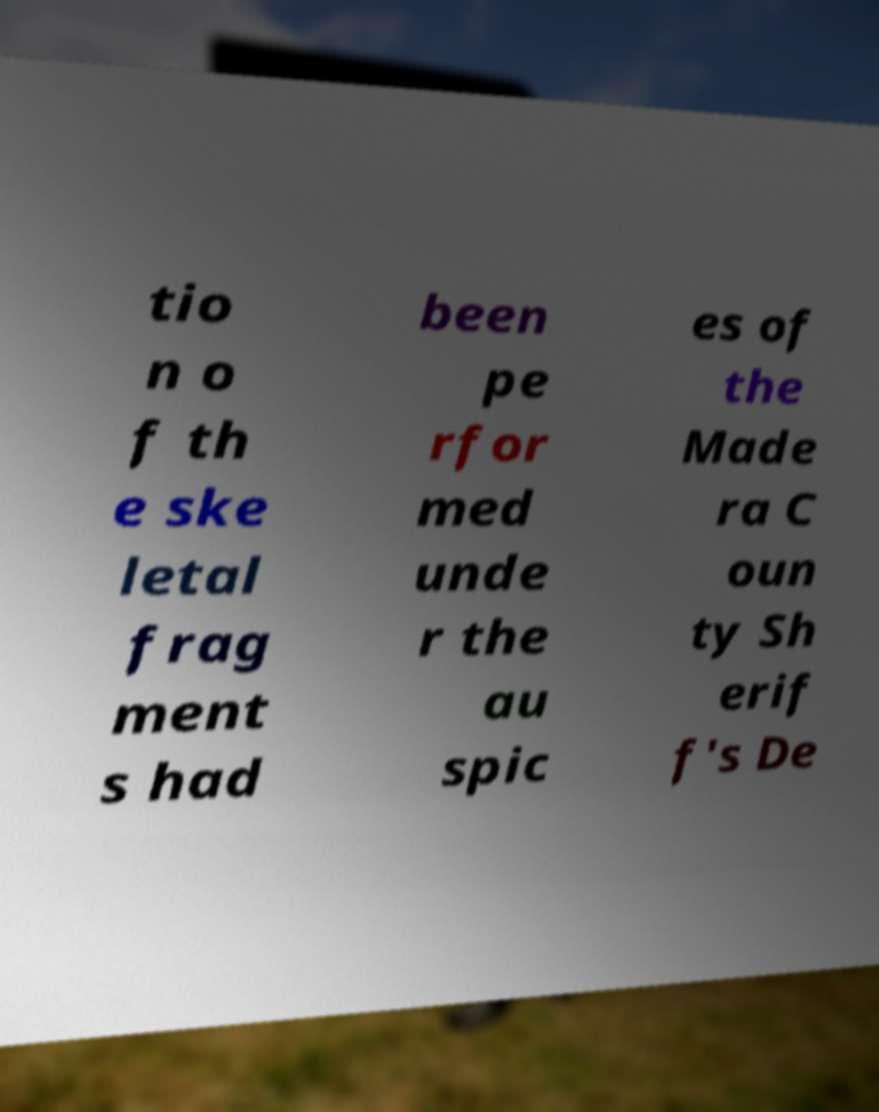Could you extract and type out the text from this image? tio n o f th e ske letal frag ment s had been pe rfor med unde r the au spic es of the Made ra C oun ty Sh erif f's De 